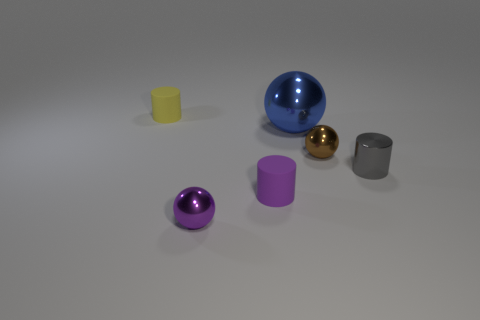Add 2 tiny yellow metallic cylinders. How many objects exist? 8 Add 3 small shiny balls. How many small shiny balls exist? 5 Subtract 0 gray balls. How many objects are left? 6 Subtract all tiny purple shiny things. Subtract all tiny balls. How many objects are left? 3 Add 4 tiny brown things. How many tiny brown things are left? 5 